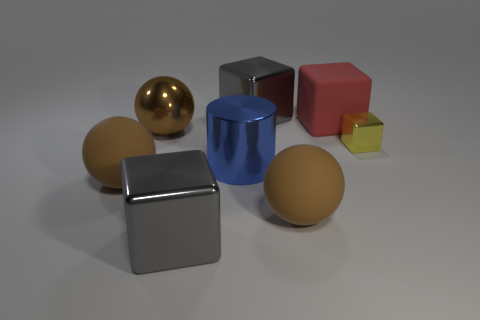How does the lighting in the image affect the objects' appearance? The lighting in the image is soft and diffused, coming from above, creating gentle shadows beneath the objects which enhance the three-dimensional effect. The way light reflects and refracts on the objects' surfaces also greatly contributes to our perception of their material properties—metallic surfaces reflect light sharply, while the matte surfaces diffuse the light and display more subtle reflections. 